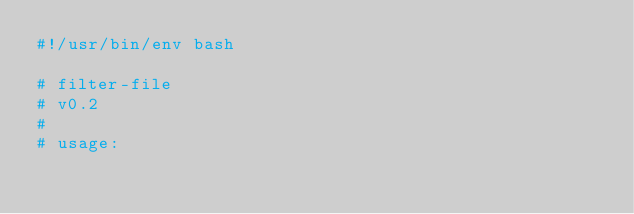<code> <loc_0><loc_0><loc_500><loc_500><_Awk_>#!/usr/bin/env bash

# filter-file
# v0.2
#
# usage:</code> 